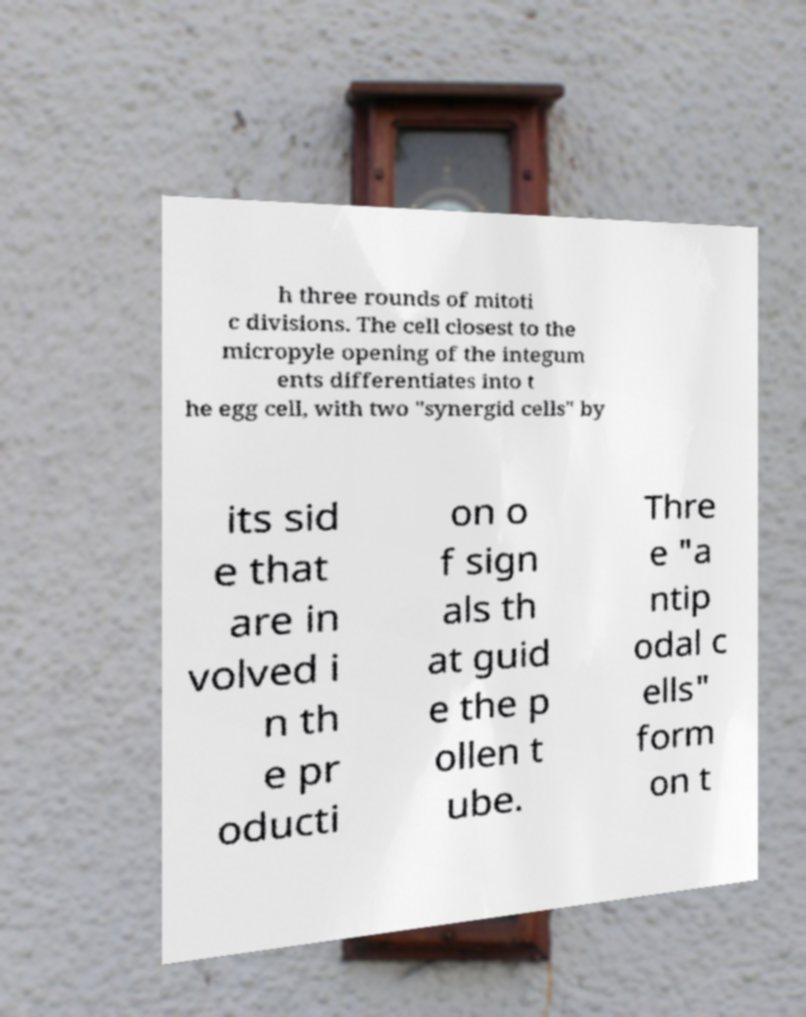I need the written content from this picture converted into text. Can you do that? h three rounds of mitoti c divisions. The cell closest to the micropyle opening of the integum ents differentiates into t he egg cell, with two "synergid cells" by its sid e that are in volved i n th e pr oducti on o f sign als th at guid e the p ollen t ube. Thre e "a ntip odal c ells" form on t 